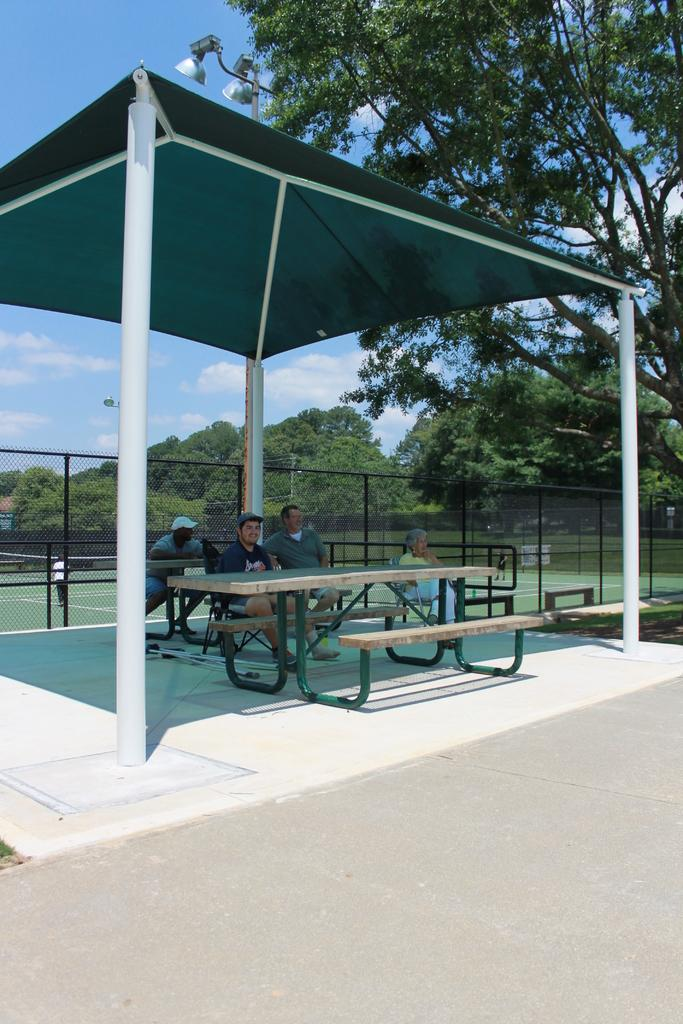What are the people in the image doing? The people in the image are sitting on benches. What structure can be seen in the image? There is a shed in the image. What type of vegetation is present in the image? There are trees in the image. What is visible in the background of the image? The sky is visible in the image. What type of prose is being recited by the trees in the image? There are no trees reciting prose in the image; the trees are simply part of the natural environment. 